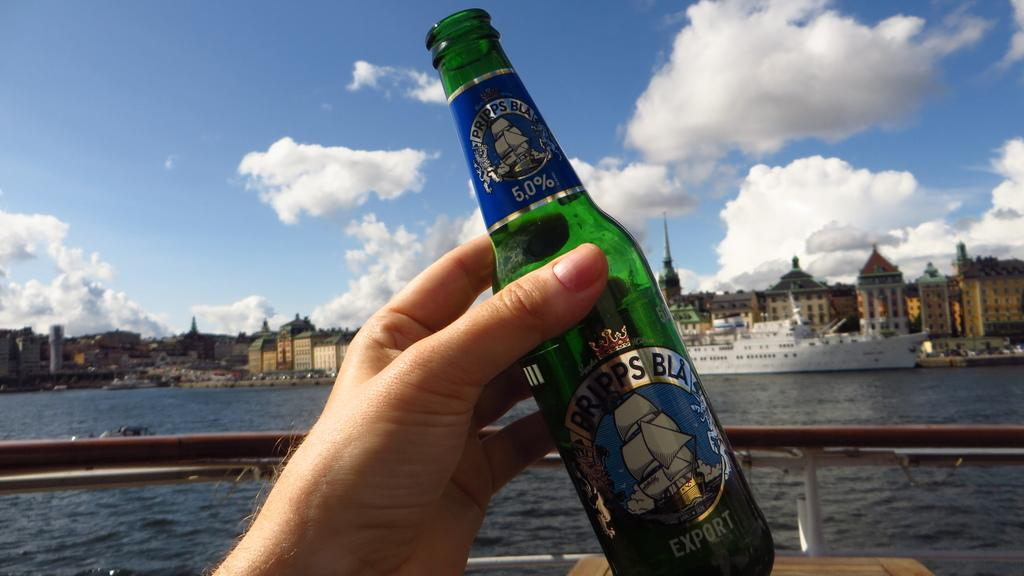<image>
Summarize the visual content of the image. A bottle of beer which the brand is Pripps Bla. 